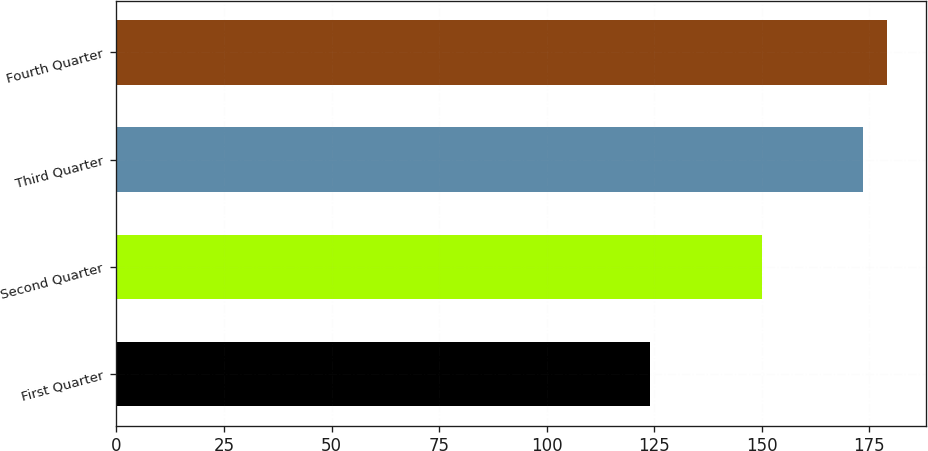<chart> <loc_0><loc_0><loc_500><loc_500><bar_chart><fcel>First Quarter<fcel>Second Quarter<fcel>Third Quarter<fcel>Fourth Quarter<nl><fcel>124.03<fcel>150.12<fcel>173.54<fcel>179.1<nl></chart> 